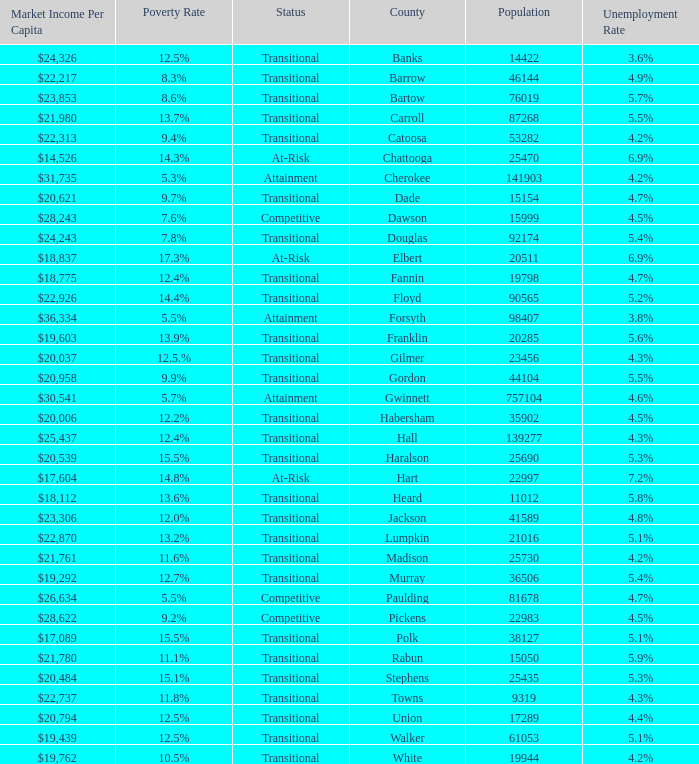What is the status of the county that has a 17.3% poverty rate? At-Risk. 